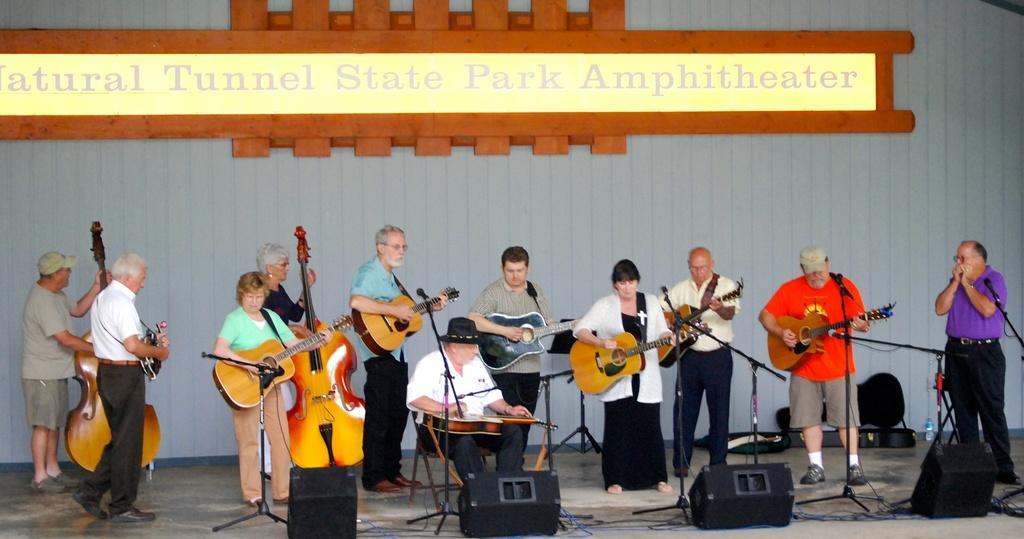Please provide a concise description of this image. In this picture we can see a group of people holding guitars in their hands and playing and some are holding violins in their hands and they are singing on mics and in front of them we have lights, wires and in background we can see wall, name. 